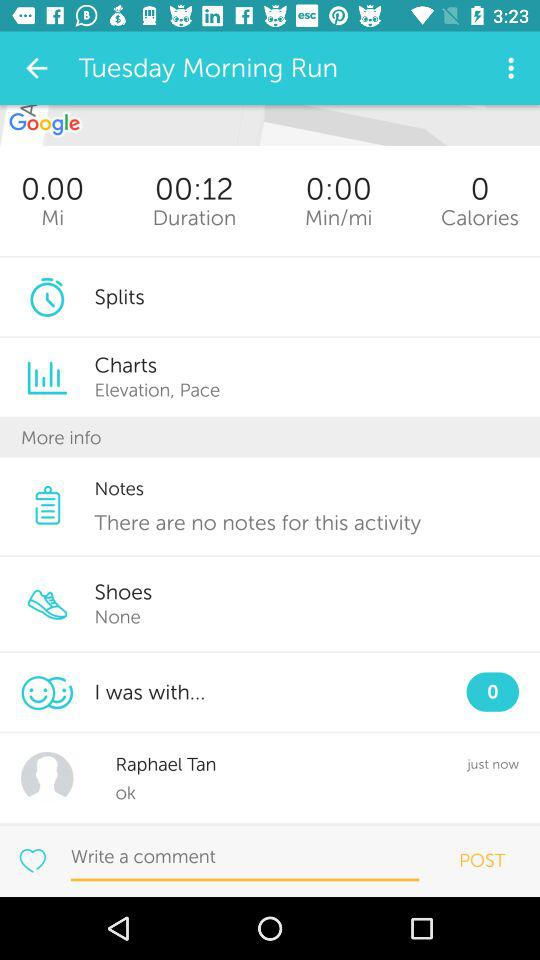Which shoes are selected? There are no selected shoes. 